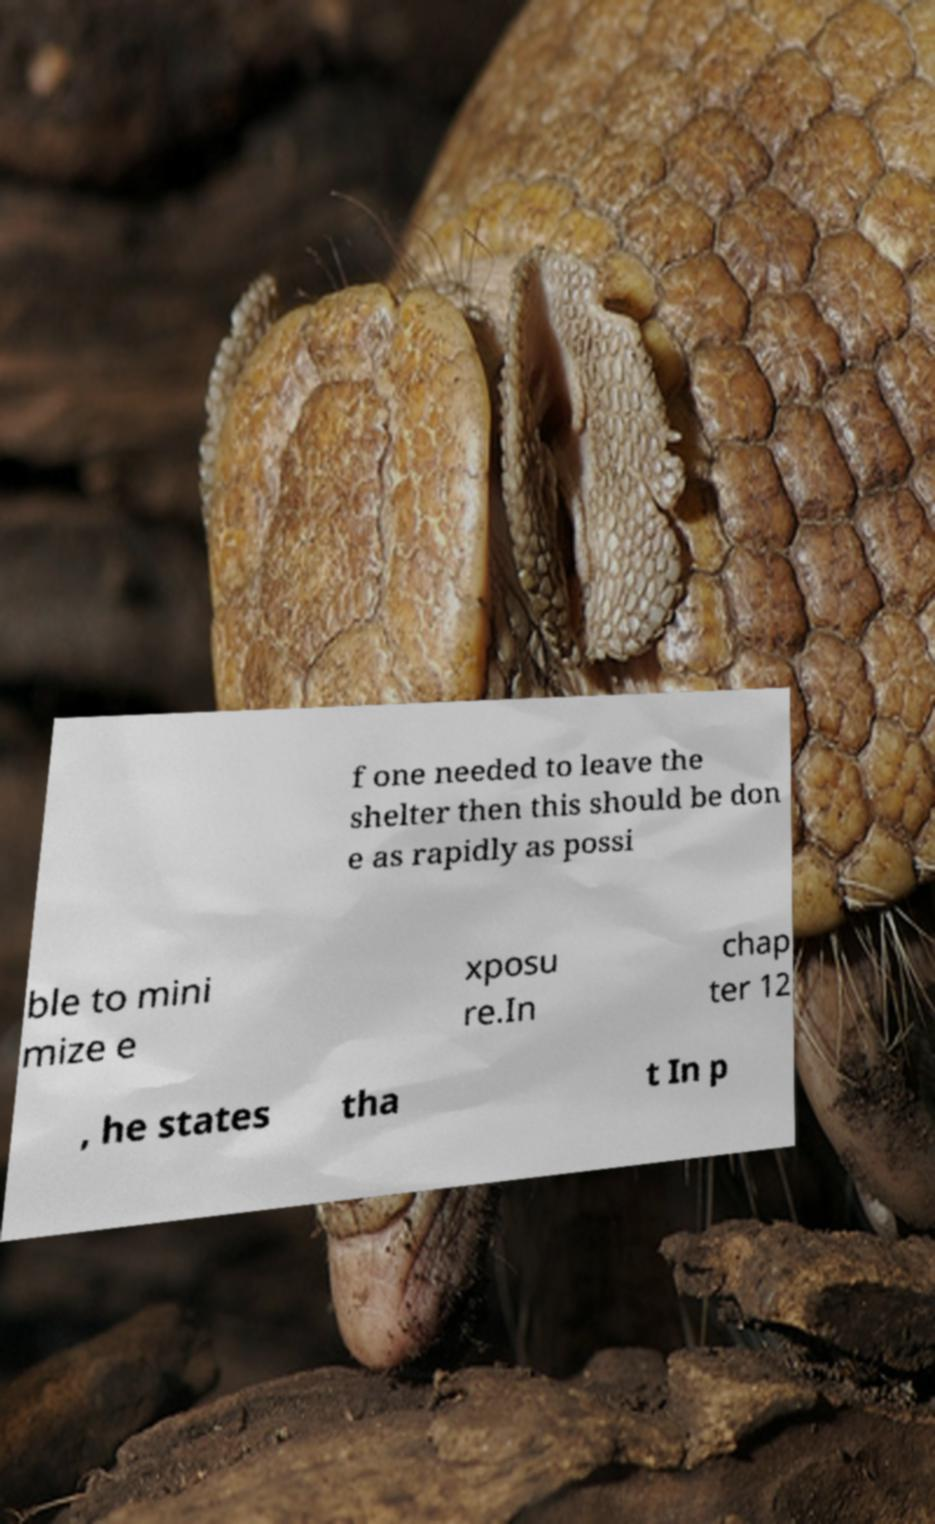Can you read and provide the text displayed in the image?This photo seems to have some interesting text. Can you extract and type it out for me? f one needed to leave the shelter then this should be don e as rapidly as possi ble to mini mize e xposu re.In chap ter 12 , he states tha t In p 